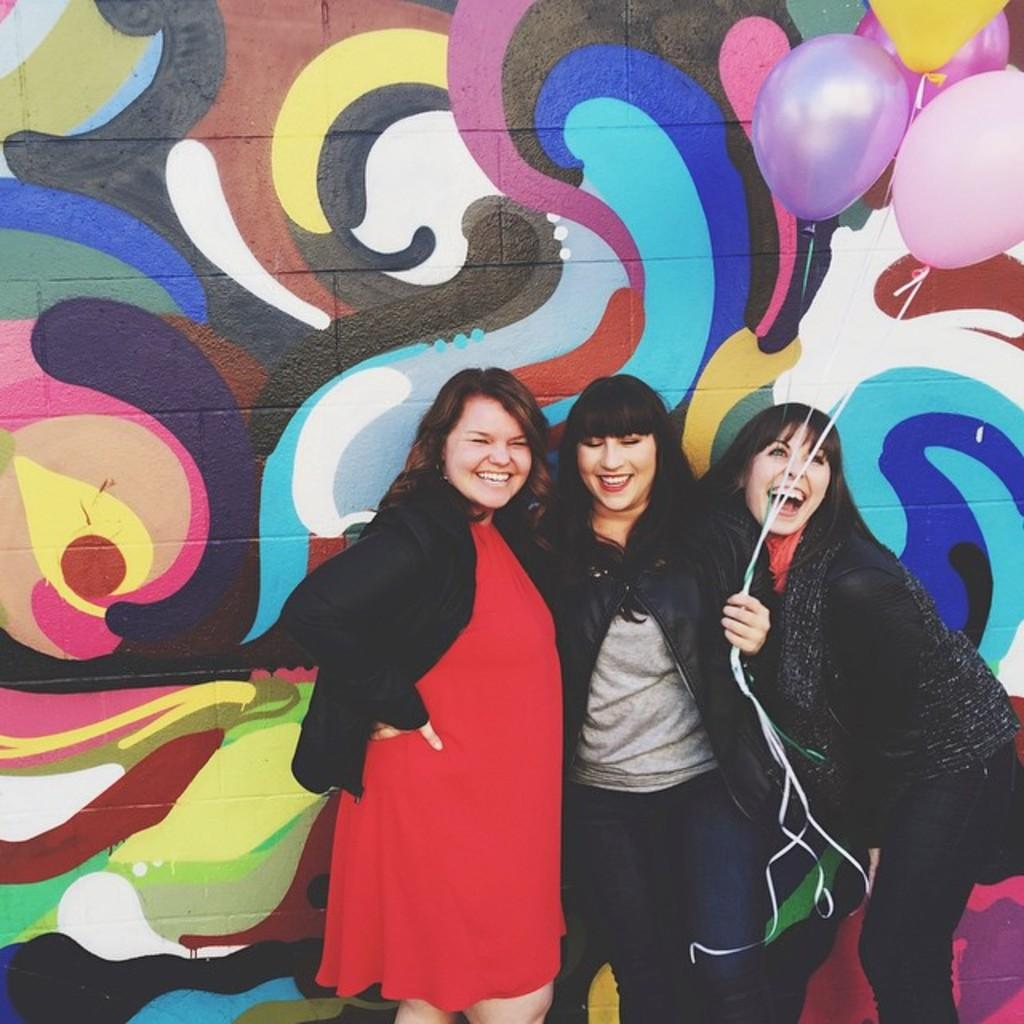How many people are in the image? There are three persons in the image. What is the person in the middle holding? The person in the middle is holding balloons. What can be seen behind the persons in the image? There is a wall visible behind the persons. What is on the wall in the image? There is a painting on the wall. What type of crayon is the person in the middle using to draw on the wall? There is no crayon present in the image, and the person in the middle is holding balloons, not drawing on the wall. 